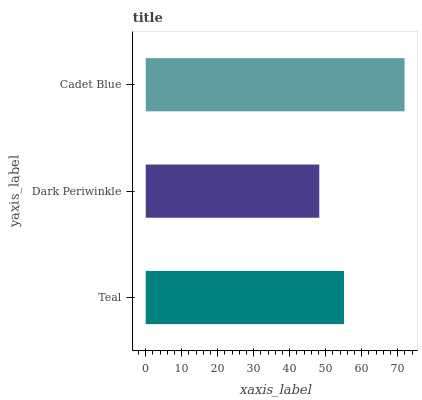Is Dark Periwinkle the minimum?
Answer yes or no. Yes. Is Cadet Blue the maximum?
Answer yes or no. Yes. Is Cadet Blue the minimum?
Answer yes or no. No. Is Dark Periwinkle the maximum?
Answer yes or no. No. Is Cadet Blue greater than Dark Periwinkle?
Answer yes or no. Yes. Is Dark Periwinkle less than Cadet Blue?
Answer yes or no. Yes. Is Dark Periwinkle greater than Cadet Blue?
Answer yes or no. No. Is Cadet Blue less than Dark Periwinkle?
Answer yes or no. No. Is Teal the high median?
Answer yes or no. Yes. Is Teal the low median?
Answer yes or no. Yes. Is Dark Periwinkle the high median?
Answer yes or no. No. Is Cadet Blue the low median?
Answer yes or no. No. 